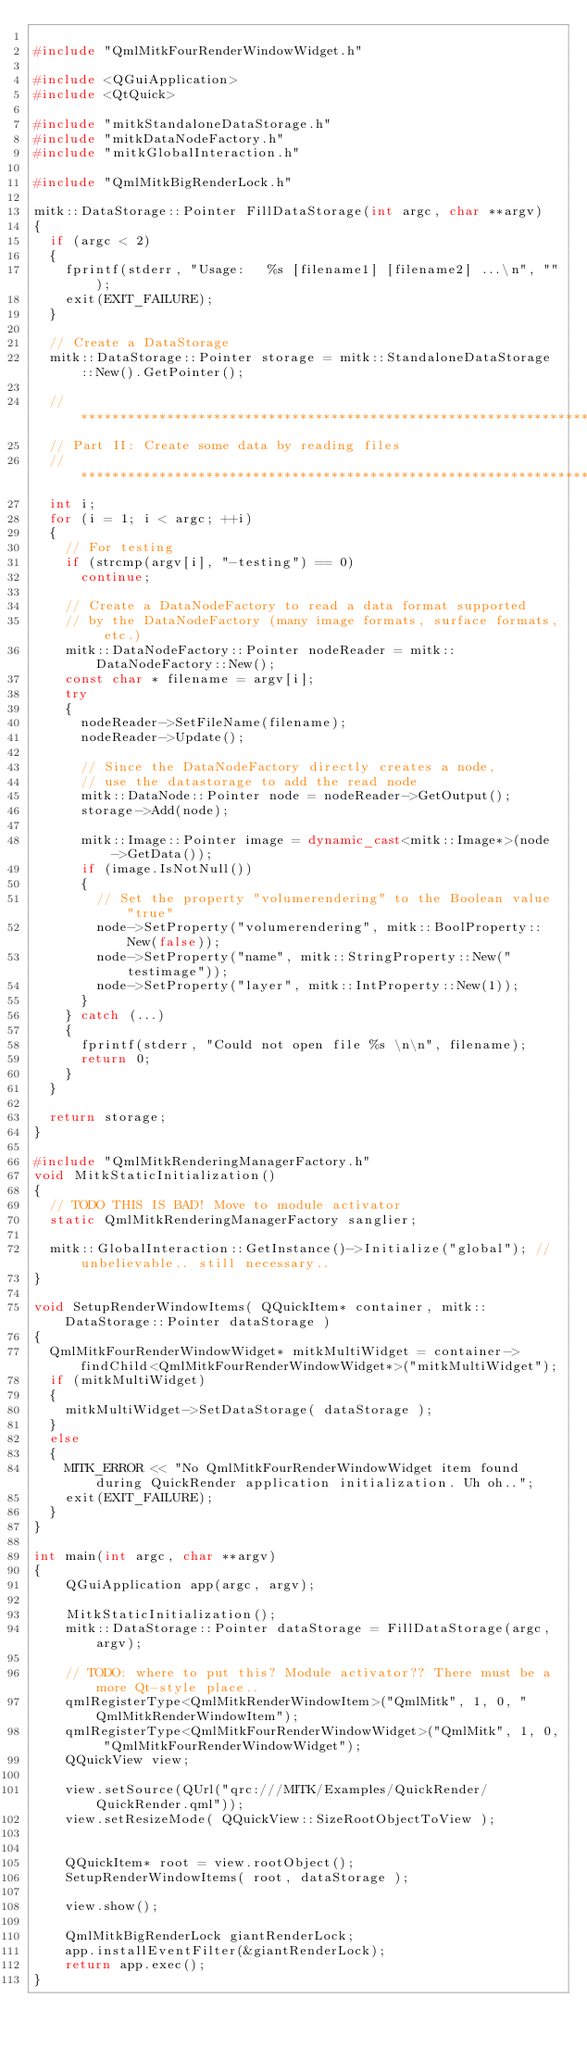<code> <loc_0><loc_0><loc_500><loc_500><_C++_>
#include "QmlMitkFourRenderWindowWidget.h"

#include <QGuiApplication>
#include <QtQuick>

#include "mitkStandaloneDataStorage.h"
#include "mitkDataNodeFactory.h"
#include "mitkGlobalInteraction.h"

#include "QmlMitkBigRenderLock.h"

mitk::DataStorage::Pointer FillDataStorage(int argc, char **argv)
{
  if (argc < 2)
  {
    fprintf(stderr, "Usage:   %s [filename1] [filename2] ...\n", "");
    exit(EXIT_FAILURE);
  }

  // Create a DataStorage
  mitk::DataStorage::Pointer storage = mitk::StandaloneDataStorage::New().GetPointer();

  //*************************************************************************
  // Part II: Create some data by reading files
  //*************************************************************************
  int i;
  for (i = 1; i < argc; ++i)
  {
    // For testing
    if (strcmp(argv[i], "-testing") == 0)
      continue;

    // Create a DataNodeFactory to read a data format supported
    // by the DataNodeFactory (many image formats, surface formats, etc.)
    mitk::DataNodeFactory::Pointer nodeReader = mitk::DataNodeFactory::New();
    const char * filename = argv[i];
    try
    {
      nodeReader->SetFileName(filename);
      nodeReader->Update();

      // Since the DataNodeFactory directly creates a node,
      // use the datastorage to add the read node
      mitk::DataNode::Pointer node = nodeReader->GetOutput();
      storage->Add(node);

      mitk::Image::Pointer image = dynamic_cast<mitk::Image*>(node->GetData());
      if (image.IsNotNull())
      {
        // Set the property "volumerendering" to the Boolean value "true"
        node->SetProperty("volumerendering", mitk::BoolProperty::New(false));
        node->SetProperty("name", mitk::StringProperty::New("testimage"));
        node->SetProperty("layer", mitk::IntProperty::New(1));
      }
    } catch (...)
    {
      fprintf(stderr, "Could not open file %s \n\n", filename);
      return 0;
    }
  }

  return storage;
}

#include "QmlMitkRenderingManagerFactory.h"
void MitkStaticInitialization()
{
  // TODO THIS IS BAD! Move to module activator
  static QmlMitkRenderingManagerFactory sanglier;

  mitk::GlobalInteraction::GetInstance()->Initialize("global"); // unbelievable.. still necessary..
}

void SetupRenderWindowItems( QQuickItem* container, mitk::DataStorage::Pointer dataStorage )
{
  QmlMitkFourRenderWindowWidget* mitkMultiWidget = container->findChild<QmlMitkFourRenderWindowWidget*>("mitkMultiWidget");
  if (mitkMultiWidget)
  {
    mitkMultiWidget->SetDataStorage( dataStorage );
  }
  else
  {
    MITK_ERROR << "No QmlMitkFourRenderWindowWidget item found during QuickRender application initialization. Uh oh..";
    exit(EXIT_FAILURE);
  }
}

int main(int argc, char **argv)
{
    QGuiApplication app(argc, argv);

    MitkStaticInitialization();
    mitk::DataStorage::Pointer dataStorage = FillDataStorage(argc,argv);

    // TODO: where to put this? Module activator?? There must be a more Qt-style place..
    qmlRegisterType<QmlMitkRenderWindowItem>("QmlMitk", 1, 0, "QmlMitkRenderWindowItem");
    qmlRegisterType<QmlMitkFourRenderWindowWidget>("QmlMitk", 1, 0, "QmlMitkFourRenderWindowWidget");
    QQuickView view;

    view.setSource(QUrl("qrc:///MITK/Examples/QuickRender/QuickRender.qml"));
    view.setResizeMode( QQuickView::SizeRootObjectToView );


    QQuickItem* root = view.rootObject();
    SetupRenderWindowItems( root, dataStorage );

    view.show();

    QmlMitkBigRenderLock giantRenderLock;
    app.installEventFilter(&giantRenderLock);
    return app.exec();
}
</code> 